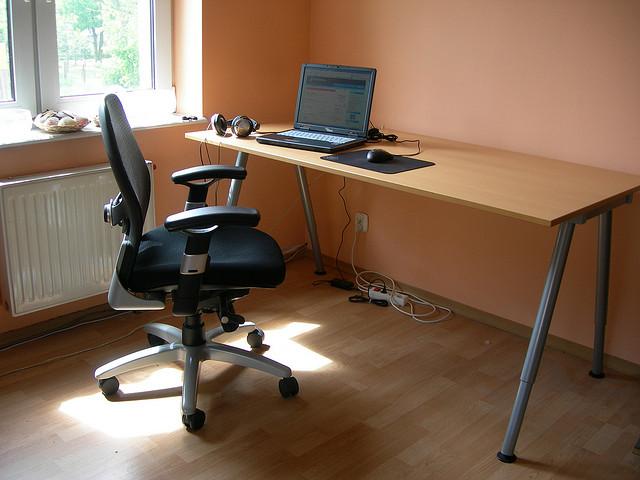How many wheels on the chair?
Give a very brief answer. 5. Is that a laptop?
Answer briefly. Yes. Are there any headphones on the desk?
Give a very brief answer. Yes. 